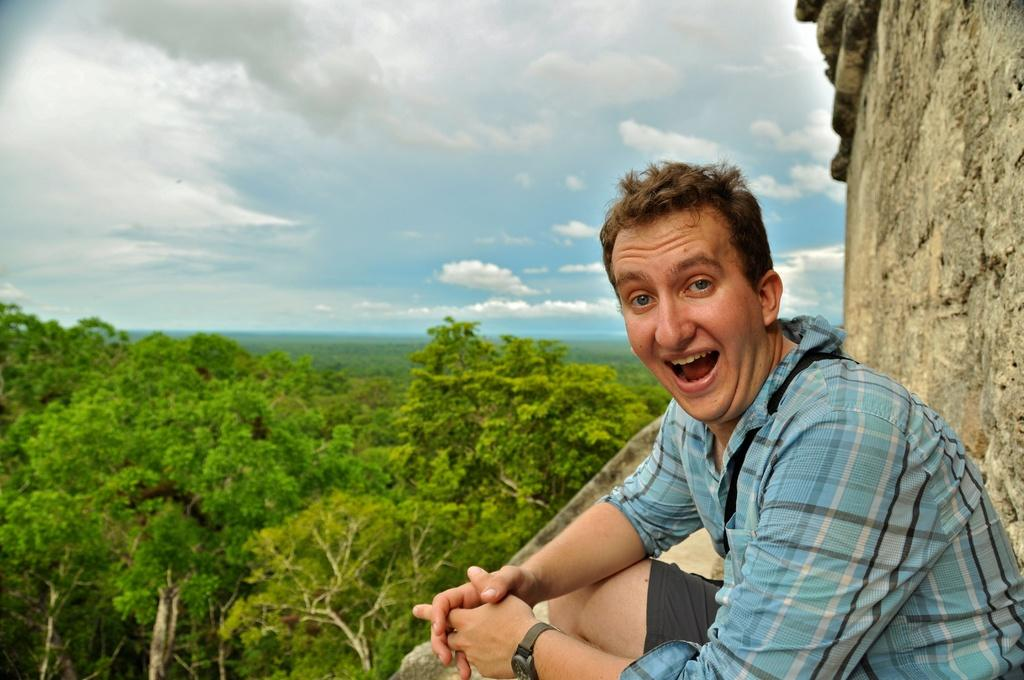Who is the main subject in the picture? There is a boy in the picture. What is the boy wearing? The boy is wearing a blue shirt. What is the boy doing in the picture? The boy is sitting and giving a pose. What can be seen in the background of the image? There is a granite fort wall in the background. What is visible in the sky in the image? The sky is visible in the image, and white clouds are present. What type of writing can be seen on the boy's shirt in the image? There is no writing visible on the boy's shirt in the image. Are there any dolls present in the image? There are no dolls present in the image; the main subject is a boy. 